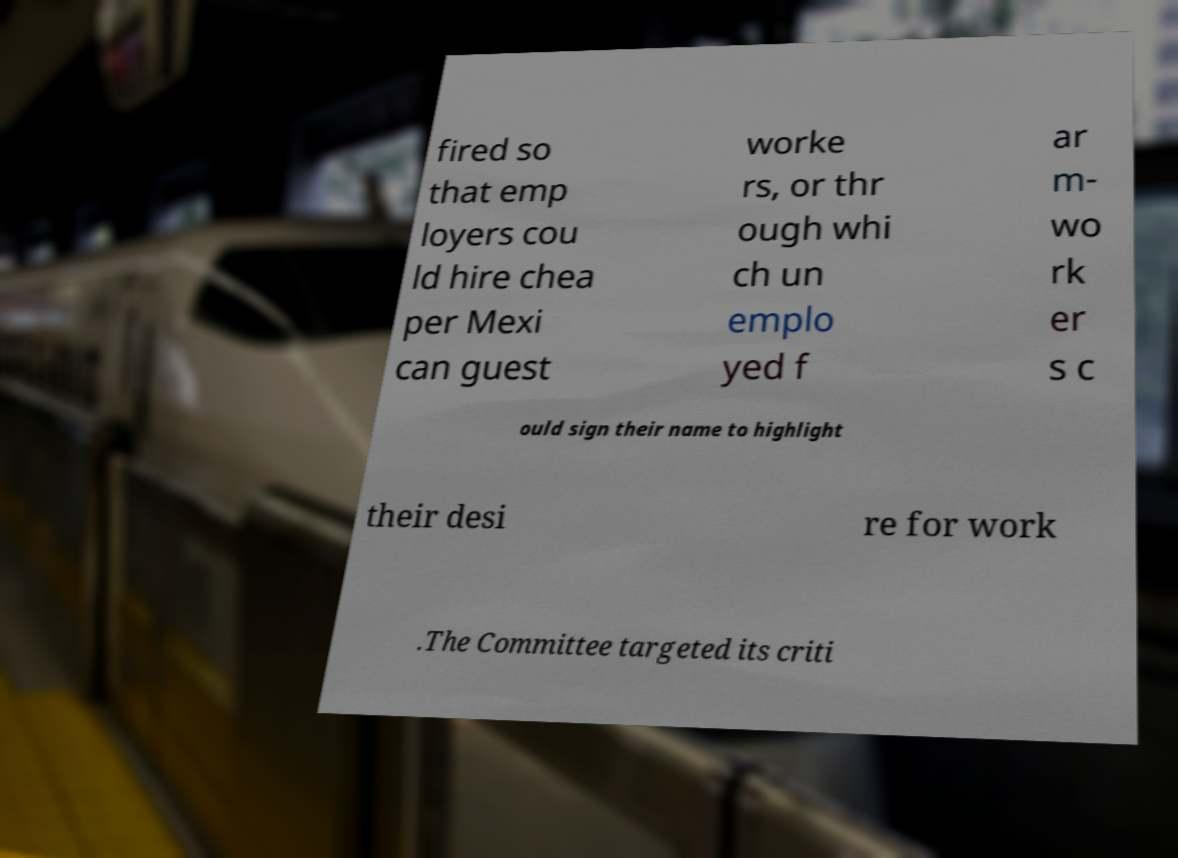What messages or text are displayed in this image? I need them in a readable, typed format. fired so that emp loyers cou ld hire chea per Mexi can guest worke rs, or thr ough whi ch un emplo yed f ar m- wo rk er s c ould sign their name to highlight their desi re for work .The Committee targeted its criti 